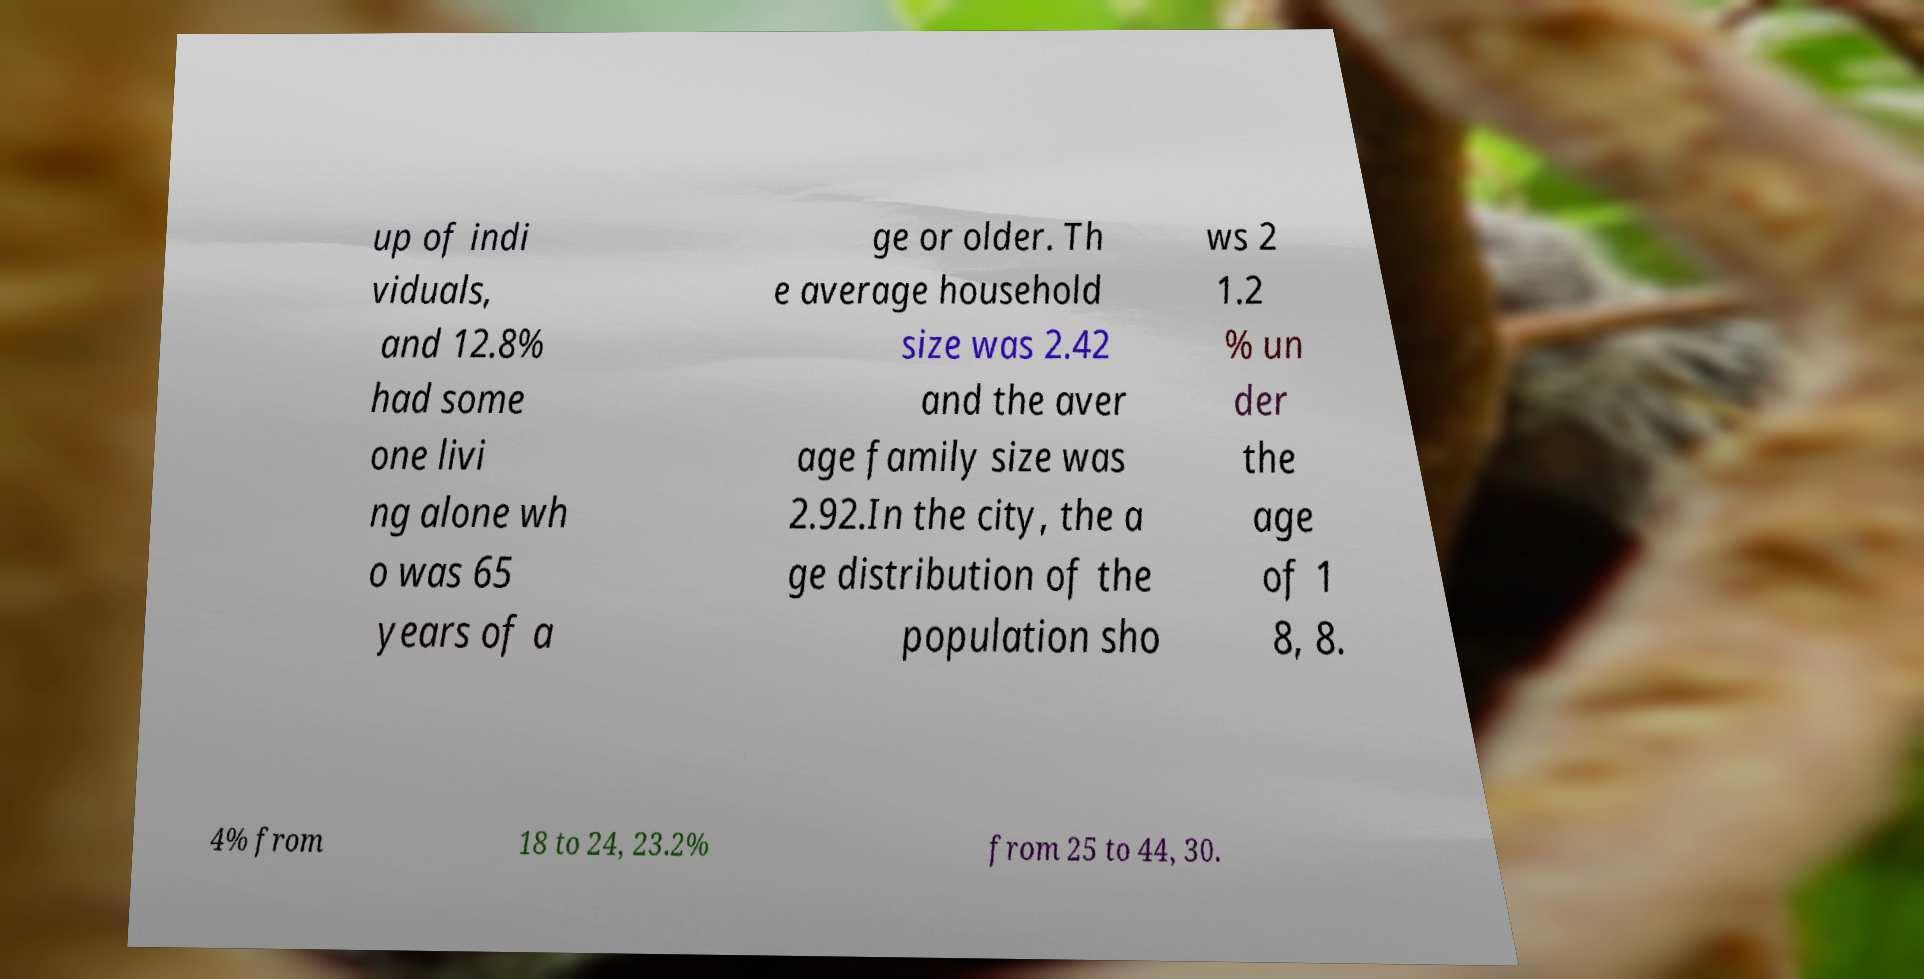Could you extract and type out the text from this image? up of indi viduals, and 12.8% had some one livi ng alone wh o was 65 years of a ge or older. Th e average household size was 2.42 and the aver age family size was 2.92.In the city, the a ge distribution of the population sho ws 2 1.2 % un der the age of 1 8, 8. 4% from 18 to 24, 23.2% from 25 to 44, 30. 